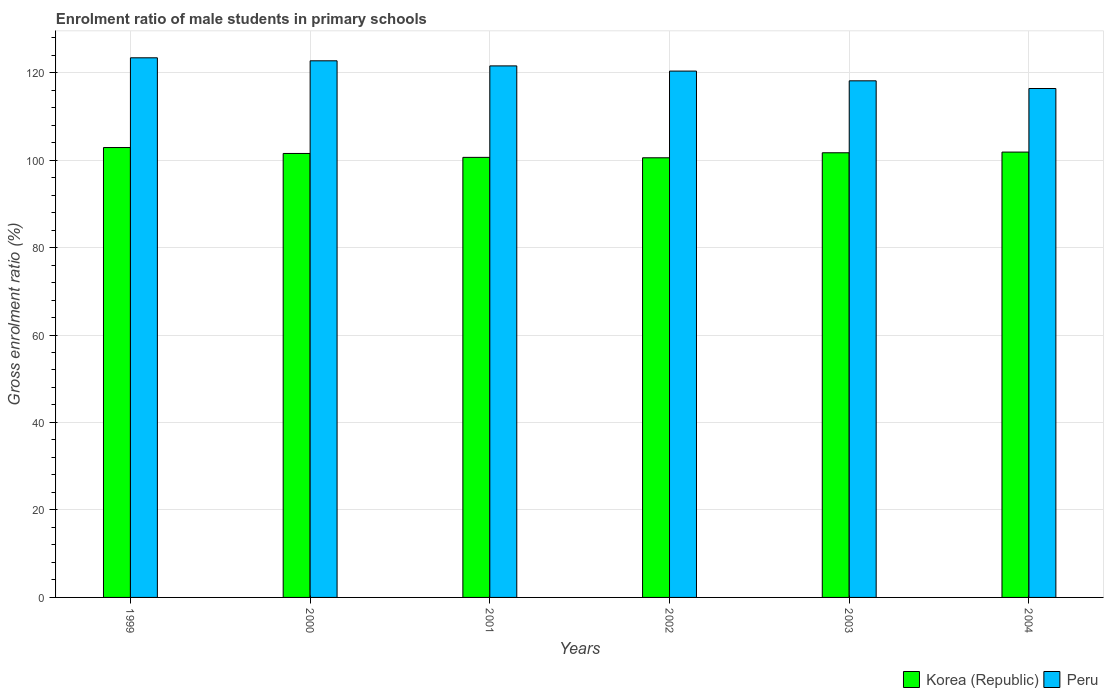How many bars are there on the 6th tick from the left?
Provide a short and direct response. 2. How many bars are there on the 2nd tick from the right?
Give a very brief answer. 2. What is the enrolment ratio of male students in primary schools in Peru in 2003?
Keep it short and to the point. 118.12. Across all years, what is the maximum enrolment ratio of male students in primary schools in Peru?
Offer a terse response. 123.38. Across all years, what is the minimum enrolment ratio of male students in primary schools in Peru?
Ensure brevity in your answer.  116.36. In which year was the enrolment ratio of male students in primary schools in Korea (Republic) maximum?
Your answer should be very brief. 1999. In which year was the enrolment ratio of male students in primary schools in Peru minimum?
Provide a succinct answer. 2004. What is the total enrolment ratio of male students in primary schools in Peru in the graph?
Ensure brevity in your answer.  722.42. What is the difference between the enrolment ratio of male students in primary schools in Korea (Republic) in 2001 and that in 2003?
Give a very brief answer. -1.05. What is the difference between the enrolment ratio of male students in primary schools in Peru in 2000 and the enrolment ratio of male students in primary schools in Korea (Republic) in 2002?
Make the answer very short. 22.18. What is the average enrolment ratio of male students in primary schools in Peru per year?
Offer a terse response. 120.4. In the year 2002, what is the difference between the enrolment ratio of male students in primary schools in Korea (Republic) and enrolment ratio of male students in primary schools in Peru?
Provide a succinct answer. -19.82. In how many years, is the enrolment ratio of male students in primary schools in Korea (Republic) greater than 56 %?
Offer a terse response. 6. What is the ratio of the enrolment ratio of male students in primary schools in Peru in 2001 to that in 2003?
Ensure brevity in your answer.  1.03. Is the difference between the enrolment ratio of male students in primary schools in Korea (Republic) in 2002 and 2003 greater than the difference between the enrolment ratio of male students in primary schools in Peru in 2002 and 2003?
Provide a succinct answer. No. What is the difference between the highest and the second highest enrolment ratio of male students in primary schools in Korea (Republic)?
Your answer should be very brief. 1.04. What is the difference between the highest and the lowest enrolment ratio of male students in primary schools in Peru?
Give a very brief answer. 7.02. In how many years, is the enrolment ratio of male students in primary schools in Peru greater than the average enrolment ratio of male students in primary schools in Peru taken over all years?
Your answer should be very brief. 3. What does the 1st bar from the left in 1999 represents?
Keep it short and to the point. Korea (Republic). How many bars are there?
Your answer should be very brief. 12. Are all the bars in the graph horizontal?
Keep it short and to the point. No. How many years are there in the graph?
Give a very brief answer. 6. What is the difference between two consecutive major ticks on the Y-axis?
Your answer should be compact. 20. Are the values on the major ticks of Y-axis written in scientific E-notation?
Your answer should be very brief. No. Does the graph contain grids?
Your response must be concise. Yes. What is the title of the graph?
Your answer should be very brief. Enrolment ratio of male students in primary schools. Does "Azerbaijan" appear as one of the legend labels in the graph?
Keep it short and to the point. No. What is the label or title of the Y-axis?
Offer a very short reply. Gross enrolment ratio (%). What is the Gross enrolment ratio (%) of Korea (Republic) in 1999?
Your response must be concise. 102.86. What is the Gross enrolment ratio (%) in Peru in 1999?
Your answer should be very brief. 123.38. What is the Gross enrolment ratio (%) in Korea (Republic) in 2000?
Offer a terse response. 101.51. What is the Gross enrolment ratio (%) of Peru in 2000?
Your answer should be very brief. 122.69. What is the Gross enrolment ratio (%) of Korea (Republic) in 2001?
Ensure brevity in your answer.  100.61. What is the Gross enrolment ratio (%) of Peru in 2001?
Provide a short and direct response. 121.53. What is the Gross enrolment ratio (%) in Korea (Republic) in 2002?
Keep it short and to the point. 100.52. What is the Gross enrolment ratio (%) in Peru in 2002?
Keep it short and to the point. 120.34. What is the Gross enrolment ratio (%) of Korea (Republic) in 2003?
Your answer should be very brief. 101.66. What is the Gross enrolment ratio (%) in Peru in 2003?
Give a very brief answer. 118.12. What is the Gross enrolment ratio (%) in Korea (Republic) in 2004?
Provide a short and direct response. 101.82. What is the Gross enrolment ratio (%) of Peru in 2004?
Ensure brevity in your answer.  116.36. Across all years, what is the maximum Gross enrolment ratio (%) of Korea (Republic)?
Your answer should be very brief. 102.86. Across all years, what is the maximum Gross enrolment ratio (%) in Peru?
Your response must be concise. 123.38. Across all years, what is the minimum Gross enrolment ratio (%) of Korea (Republic)?
Your response must be concise. 100.52. Across all years, what is the minimum Gross enrolment ratio (%) in Peru?
Provide a short and direct response. 116.36. What is the total Gross enrolment ratio (%) of Korea (Republic) in the graph?
Give a very brief answer. 608.99. What is the total Gross enrolment ratio (%) in Peru in the graph?
Your answer should be very brief. 722.42. What is the difference between the Gross enrolment ratio (%) of Korea (Republic) in 1999 and that in 2000?
Provide a succinct answer. 1.35. What is the difference between the Gross enrolment ratio (%) in Peru in 1999 and that in 2000?
Provide a succinct answer. 0.68. What is the difference between the Gross enrolment ratio (%) of Korea (Republic) in 1999 and that in 2001?
Make the answer very short. 2.25. What is the difference between the Gross enrolment ratio (%) of Peru in 1999 and that in 2001?
Your answer should be very brief. 1.85. What is the difference between the Gross enrolment ratio (%) of Korea (Republic) in 1999 and that in 2002?
Make the answer very short. 2.34. What is the difference between the Gross enrolment ratio (%) in Peru in 1999 and that in 2002?
Your response must be concise. 3.04. What is the difference between the Gross enrolment ratio (%) in Korea (Republic) in 1999 and that in 2003?
Your answer should be compact. 1.2. What is the difference between the Gross enrolment ratio (%) in Peru in 1999 and that in 2003?
Offer a very short reply. 5.26. What is the difference between the Gross enrolment ratio (%) of Korea (Republic) in 1999 and that in 2004?
Provide a short and direct response. 1.04. What is the difference between the Gross enrolment ratio (%) in Peru in 1999 and that in 2004?
Provide a succinct answer. 7.02. What is the difference between the Gross enrolment ratio (%) in Korea (Republic) in 2000 and that in 2001?
Ensure brevity in your answer.  0.9. What is the difference between the Gross enrolment ratio (%) of Peru in 2000 and that in 2001?
Make the answer very short. 1.16. What is the difference between the Gross enrolment ratio (%) in Peru in 2000 and that in 2002?
Make the answer very short. 2.35. What is the difference between the Gross enrolment ratio (%) in Korea (Republic) in 2000 and that in 2003?
Your answer should be very brief. -0.15. What is the difference between the Gross enrolment ratio (%) of Peru in 2000 and that in 2003?
Your response must be concise. 4.58. What is the difference between the Gross enrolment ratio (%) in Korea (Republic) in 2000 and that in 2004?
Your response must be concise. -0.31. What is the difference between the Gross enrolment ratio (%) of Peru in 2000 and that in 2004?
Provide a short and direct response. 6.34. What is the difference between the Gross enrolment ratio (%) in Korea (Republic) in 2001 and that in 2002?
Give a very brief answer. 0.1. What is the difference between the Gross enrolment ratio (%) in Peru in 2001 and that in 2002?
Offer a very short reply. 1.19. What is the difference between the Gross enrolment ratio (%) of Korea (Republic) in 2001 and that in 2003?
Your answer should be very brief. -1.05. What is the difference between the Gross enrolment ratio (%) in Peru in 2001 and that in 2003?
Offer a terse response. 3.42. What is the difference between the Gross enrolment ratio (%) in Korea (Republic) in 2001 and that in 2004?
Offer a terse response. -1.21. What is the difference between the Gross enrolment ratio (%) of Peru in 2001 and that in 2004?
Your answer should be very brief. 5.17. What is the difference between the Gross enrolment ratio (%) in Korea (Republic) in 2002 and that in 2003?
Your answer should be very brief. -1.15. What is the difference between the Gross enrolment ratio (%) in Peru in 2002 and that in 2003?
Provide a succinct answer. 2.23. What is the difference between the Gross enrolment ratio (%) in Korea (Republic) in 2002 and that in 2004?
Provide a succinct answer. -1.31. What is the difference between the Gross enrolment ratio (%) of Peru in 2002 and that in 2004?
Provide a succinct answer. 3.98. What is the difference between the Gross enrolment ratio (%) of Korea (Republic) in 2003 and that in 2004?
Provide a succinct answer. -0.16. What is the difference between the Gross enrolment ratio (%) of Peru in 2003 and that in 2004?
Provide a succinct answer. 1.76. What is the difference between the Gross enrolment ratio (%) of Korea (Republic) in 1999 and the Gross enrolment ratio (%) of Peru in 2000?
Give a very brief answer. -19.83. What is the difference between the Gross enrolment ratio (%) of Korea (Republic) in 1999 and the Gross enrolment ratio (%) of Peru in 2001?
Your answer should be compact. -18.67. What is the difference between the Gross enrolment ratio (%) in Korea (Republic) in 1999 and the Gross enrolment ratio (%) in Peru in 2002?
Your response must be concise. -17.48. What is the difference between the Gross enrolment ratio (%) of Korea (Republic) in 1999 and the Gross enrolment ratio (%) of Peru in 2003?
Ensure brevity in your answer.  -15.25. What is the difference between the Gross enrolment ratio (%) of Korea (Republic) in 1999 and the Gross enrolment ratio (%) of Peru in 2004?
Your response must be concise. -13.5. What is the difference between the Gross enrolment ratio (%) in Korea (Republic) in 2000 and the Gross enrolment ratio (%) in Peru in 2001?
Keep it short and to the point. -20.02. What is the difference between the Gross enrolment ratio (%) of Korea (Republic) in 2000 and the Gross enrolment ratio (%) of Peru in 2002?
Offer a terse response. -18.83. What is the difference between the Gross enrolment ratio (%) in Korea (Republic) in 2000 and the Gross enrolment ratio (%) in Peru in 2003?
Offer a very short reply. -16.61. What is the difference between the Gross enrolment ratio (%) in Korea (Republic) in 2000 and the Gross enrolment ratio (%) in Peru in 2004?
Your response must be concise. -14.85. What is the difference between the Gross enrolment ratio (%) of Korea (Republic) in 2001 and the Gross enrolment ratio (%) of Peru in 2002?
Offer a very short reply. -19.73. What is the difference between the Gross enrolment ratio (%) in Korea (Republic) in 2001 and the Gross enrolment ratio (%) in Peru in 2003?
Ensure brevity in your answer.  -17.5. What is the difference between the Gross enrolment ratio (%) in Korea (Republic) in 2001 and the Gross enrolment ratio (%) in Peru in 2004?
Make the answer very short. -15.74. What is the difference between the Gross enrolment ratio (%) in Korea (Republic) in 2002 and the Gross enrolment ratio (%) in Peru in 2003?
Your answer should be very brief. -17.6. What is the difference between the Gross enrolment ratio (%) in Korea (Republic) in 2002 and the Gross enrolment ratio (%) in Peru in 2004?
Make the answer very short. -15.84. What is the difference between the Gross enrolment ratio (%) in Korea (Republic) in 2003 and the Gross enrolment ratio (%) in Peru in 2004?
Offer a terse response. -14.69. What is the average Gross enrolment ratio (%) in Korea (Republic) per year?
Provide a succinct answer. 101.5. What is the average Gross enrolment ratio (%) in Peru per year?
Provide a short and direct response. 120.4. In the year 1999, what is the difference between the Gross enrolment ratio (%) in Korea (Republic) and Gross enrolment ratio (%) in Peru?
Your answer should be compact. -20.52. In the year 2000, what is the difference between the Gross enrolment ratio (%) of Korea (Republic) and Gross enrolment ratio (%) of Peru?
Offer a very short reply. -21.18. In the year 2001, what is the difference between the Gross enrolment ratio (%) in Korea (Republic) and Gross enrolment ratio (%) in Peru?
Your answer should be very brief. -20.92. In the year 2002, what is the difference between the Gross enrolment ratio (%) in Korea (Republic) and Gross enrolment ratio (%) in Peru?
Offer a very short reply. -19.82. In the year 2003, what is the difference between the Gross enrolment ratio (%) of Korea (Republic) and Gross enrolment ratio (%) of Peru?
Keep it short and to the point. -16.45. In the year 2004, what is the difference between the Gross enrolment ratio (%) in Korea (Republic) and Gross enrolment ratio (%) in Peru?
Make the answer very short. -14.53. What is the ratio of the Gross enrolment ratio (%) in Korea (Republic) in 1999 to that in 2000?
Give a very brief answer. 1.01. What is the ratio of the Gross enrolment ratio (%) in Peru in 1999 to that in 2000?
Ensure brevity in your answer.  1.01. What is the ratio of the Gross enrolment ratio (%) in Korea (Republic) in 1999 to that in 2001?
Ensure brevity in your answer.  1.02. What is the ratio of the Gross enrolment ratio (%) of Peru in 1999 to that in 2001?
Make the answer very short. 1.02. What is the ratio of the Gross enrolment ratio (%) in Korea (Republic) in 1999 to that in 2002?
Ensure brevity in your answer.  1.02. What is the ratio of the Gross enrolment ratio (%) of Peru in 1999 to that in 2002?
Provide a succinct answer. 1.03. What is the ratio of the Gross enrolment ratio (%) in Korea (Republic) in 1999 to that in 2003?
Make the answer very short. 1.01. What is the ratio of the Gross enrolment ratio (%) of Peru in 1999 to that in 2003?
Ensure brevity in your answer.  1.04. What is the ratio of the Gross enrolment ratio (%) in Korea (Republic) in 1999 to that in 2004?
Provide a short and direct response. 1.01. What is the ratio of the Gross enrolment ratio (%) of Peru in 1999 to that in 2004?
Give a very brief answer. 1.06. What is the ratio of the Gross enrolment ratio (%) of Korea (Republic) in 2000 to that in 2001?
Provide a short and direct response. 1.01. What is the ratio of the Gross enrolment ratio (%) in Peru in 2000 to that in 2001?
Keep it short and to the point. 1.01. What is the ratio of the Gross enrolment ratio (%) in Korea (Republic) in 2000 to that in 2002?
Provide a short and direct response. 1.01. What is the ratio of the Gross enrolment ratio (%) in Peru in 2000 to that in 2002?
Your response must be concise. 1.02. What is the ratio of the Gross enrolment ratio (%) of Korea (Republic) in 2000 to that in 2003?
Give a very brief answer. 1. What is the ratio of the Gross enrolment ratio (%) in Peru in 2000 to that in 2003?
Make the answer very short. 1.04. What is the ratio of the Gross enrolment ratio (%) in Korea (Republic) in 2000 to that in 2004?
Provide a short and direct response. 1. What is the ratio of the Gross enrolment ratio (%) of Peru in 2000 to that in 2004?
Provide a succinct answer. 1.05. What is the ratio of the Gross enrolment ratio (%) of Peru in 2001 to that in 2002?
Keep it short and to the point. 1.01. What is the ratio of the Gross enrolment ratio (%) in Peru in 2001 to that in 2003?
Ensure brevity in your answer.  1.03. What is the ratio of the Gross enrolment ratio (%) of Korea (Republic) in 2001 to that in 2004?
Offer a very short reply. 0.99. What is the ratio of the Gross enrolment ratio (%) in Peru in 2001 to that in 2004?
Provide a succinct answer. 1.04. What is the ratio of the Gross enrolment ratio (%) of Korea (Republic) in 2002 to that in 2003?
Your answer should be very brief. 0.99. What is the ratio of the Gross enrolment ratio (%) of Peru in 2002 to that in 2003?
Keep it short and to the point. 1.02. What is the ratio of the Gross enrolment ratio (%) of Korea (Republic) in 2002 to that in 2004?
Provide a succinct answer. 0.99. What is the ratio of the Gross enrolment ratio (%) in Peru in 2002 to that in 2004?
Offer a very short reply. 1.03. What is the ratio of the Gross enrolment ratio (%) of Korea (Republic) in 2003 to that in 2004?
Offer a terse response. 1. What is the ratio of the Gross enrolment ratio (%) of Peru in 2003 to that in 2004?
Your answer should be compact. 1.02. What is the difference between the highest and the second highest Gross enrolment ratio (%) of Korea (Republic)?
Keep it short and to the point. 1.04. What is the difference between the highest and the second highest Gross enrolment ratio (%) in Peru?
Ensure brevity in your answer.  0.68. What is the difference between the highest and the lowest Gross enrolment ratio (%) of Korea (Republic)?
Make the answer very short. 2.34. What is the difference between the highest and the lowest Gross enrolment ratio (%) of Peru?
Keep it short and to the point. 7.02. 